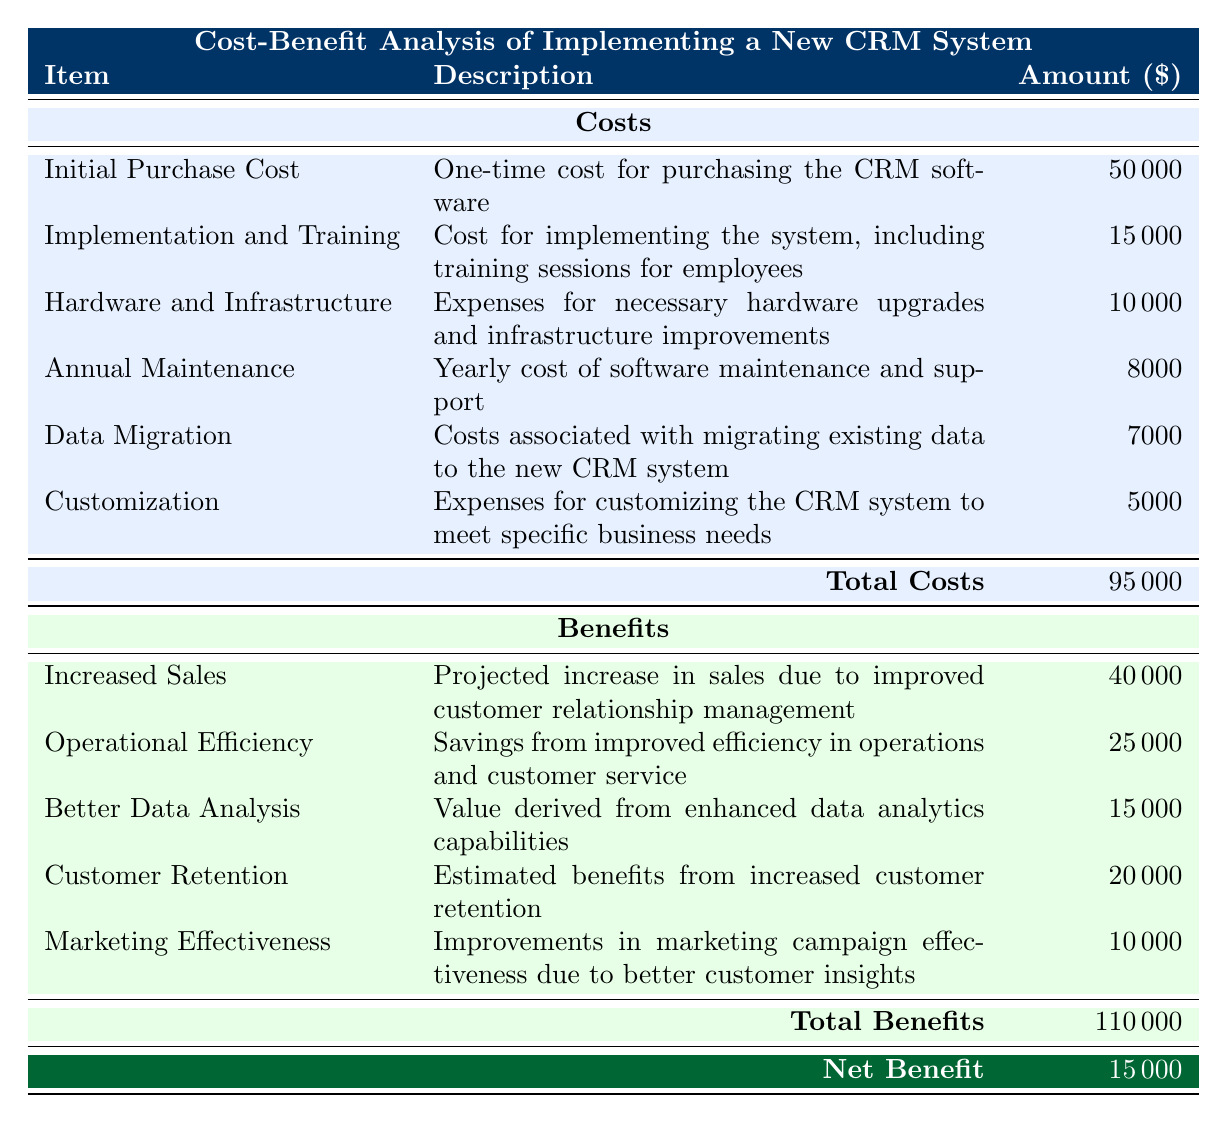What is the total initial purchase cost of the CRM software? The initial purchase cost is listed directly in the table, specifically under "Initial Purchase Cost" with an amount of 50000.
Answer: 50000 How much is spent on implementation and training? The implementation and training cost is stated under the corresponding row, which is 15000.
Answer: 15000 What is the total cost incurred for data migration and customization combined? The total cost for data migration is 7000, and the customization cost is 5000. Adding these together gives: 7000 + 5000 = 12000.
Answer: 12000 Is the annual maintenance cost greater than the data migration cost? The annual maintenance cost is 8000 while the data migration cost is 7000. Since 8000 is greater than 7000, the statement is true.
Answer: Yes What is the net benefit from implementing the new CRM system? The net benefit is determined by subtracting total costs from total benefits. Total costs amount to 95000 and total benefits amount to 110000. Therefore, the net benefit is 110000 - 95000 = 15000.
Answer: 15000 Which benefit category has the highest projected amount? By looking at the benefits listed, "Increased Sales" shows the highest projected benefit amount at 40000.
Answer: Increased Sales How much greater are the total benefits than the total costs? The total benefits are 110000, and total costs are 95000. The difference is calculated as 110000 - 95000 = 15000.
Answer: 15000 Does the sum of operational efficiency and customer retention benefits exceed the amount for better data analysis? The amounts for operational efficiency (25000) and customer retention (20000) add up to 45000. The amount for better data analysis is 15000. Since 45000 is greater than 15000, the statement is true.
Answer: Yes What is the average annual maintenance cost over 5 years? Since the annual maintenance cost is 8000, to find the average over 5 years, we consider the same annual value without averaging across different values, hence it's simply 8000.
Answer: 8000 